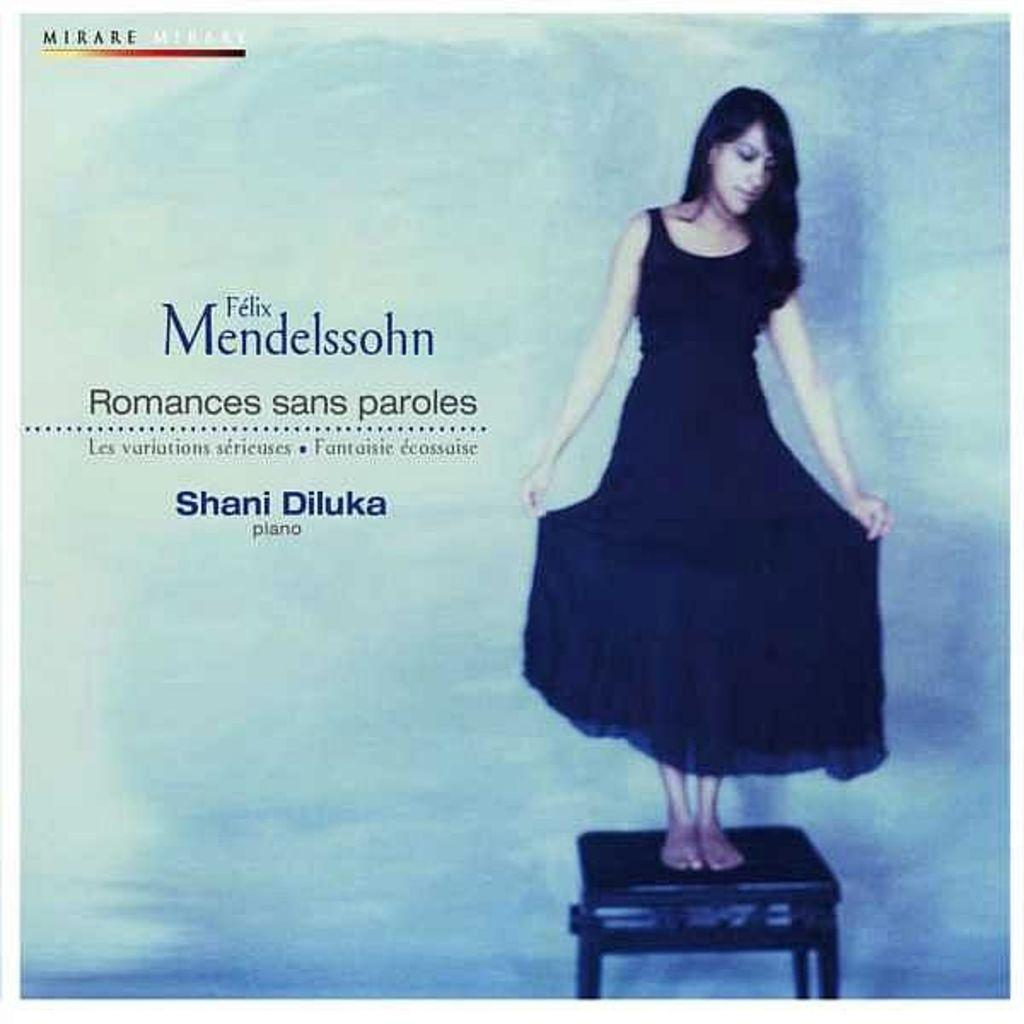Who is the main subject in the image? There is a woman in the image. What is the woman doing in the image? The woman is standing on a stool. What else can be seen on the left side of the image? There is text on the left side of the image. Can you describe the text in the top left corner of the image? There is text in the top left corner of the image. What type of coil is visible in the image? There is no coil present in the image. Who is the porter in the image? There is no porter present in the image. 